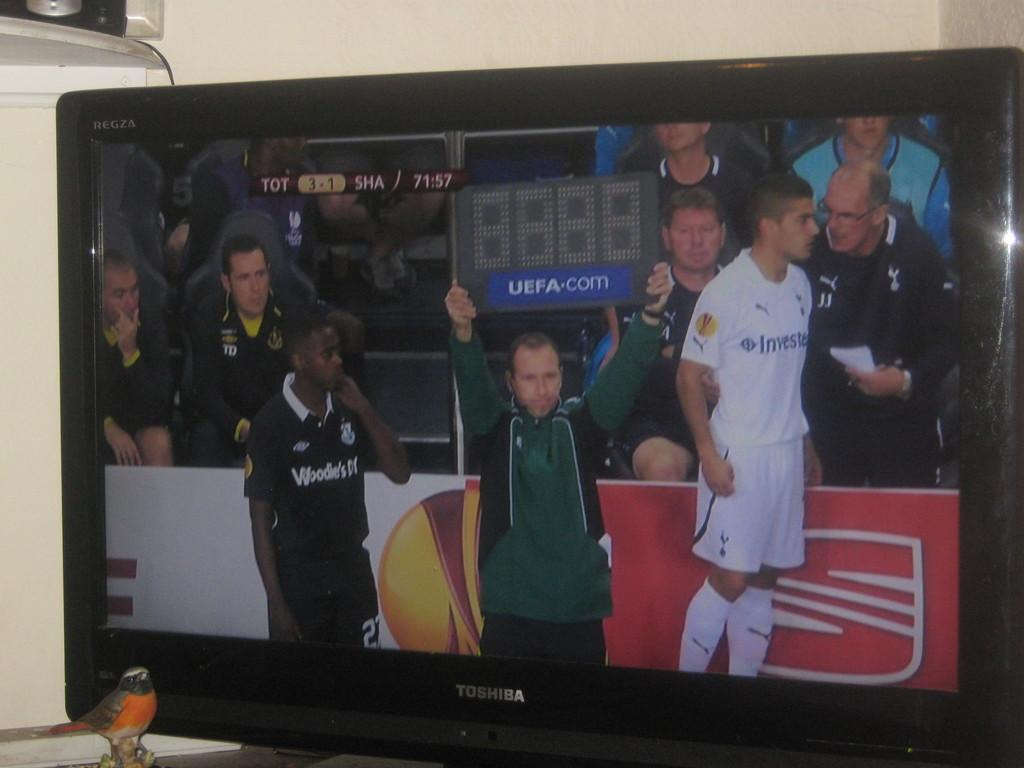<image>
Describe the image concisely. A man is holding up a blank scoreboard that also reads UEFA.com 